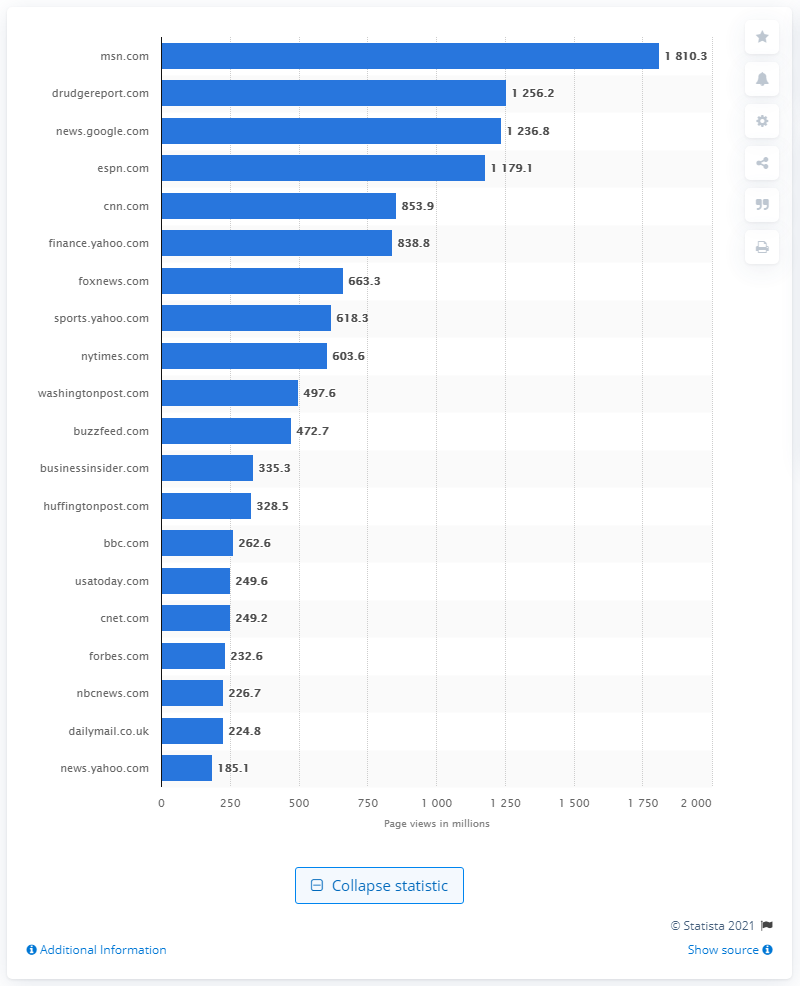Highlight a few significant elements in this photo. In May 2017, MSN received 1810.3 pageviews. 